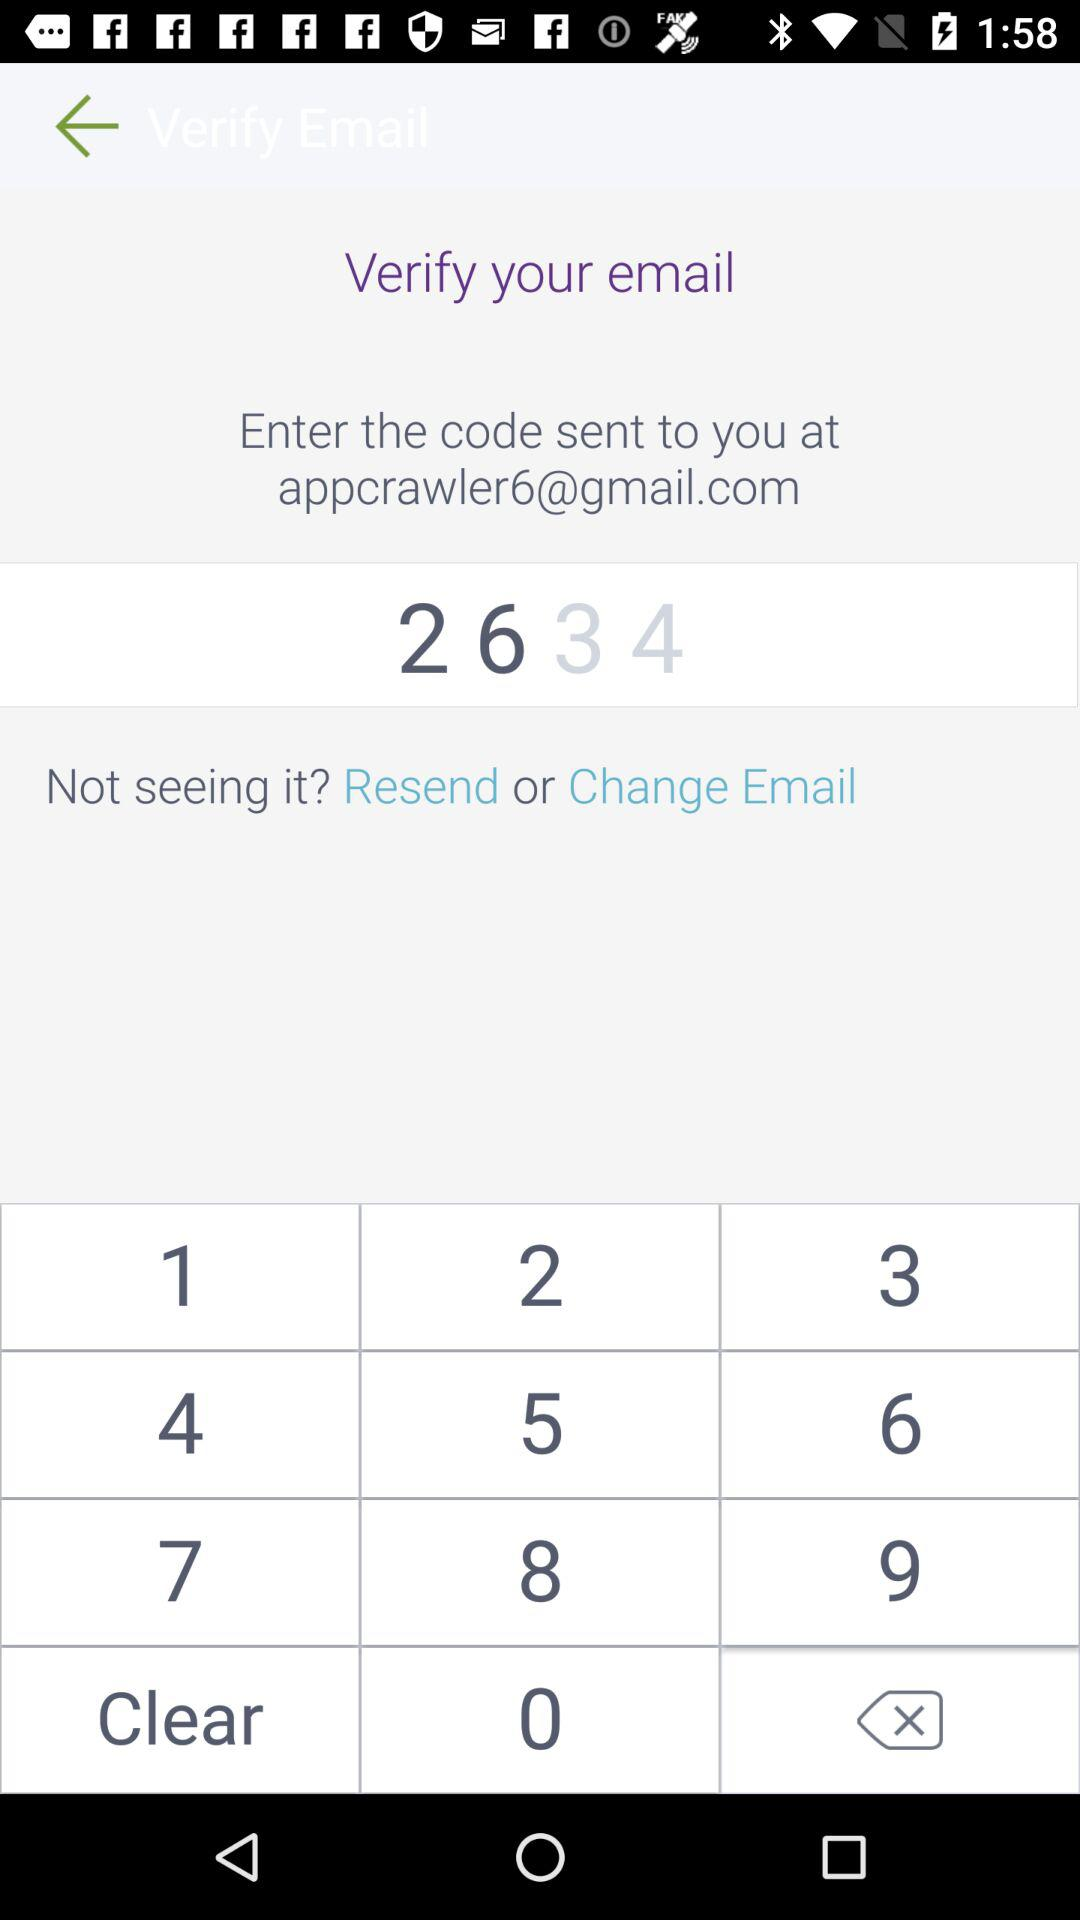What is the email address? The email address is appcrawler6@gmail.com. 